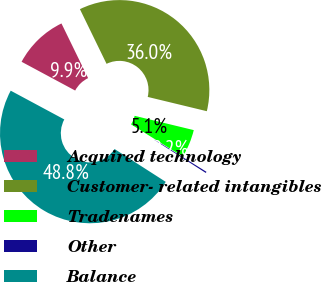Convert chart. <chart><loc_0><loc_0><loc_500><loc_500><pie_chart><fcel>Acquired technology<fcel>Customer- related intangibles<fcel>Tradenames<fcel>Other<fcel>Balance<nl><fcel>9.94%<fcel>35.99%<fcel>5.08%<fcel>0.23%<fcel>48.76%<nl></chart> 